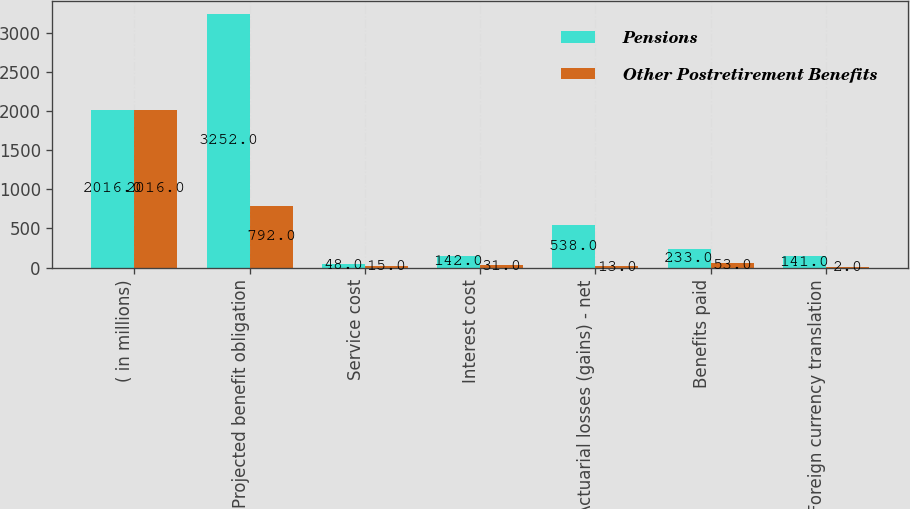Convert chart. <chart><loc_0><loc_0><loc_500><loc_500><stacked_bar_chart><ecel><fcel>( in millions)<fcel>Projected benefit obligation<fcel>Service cost<fcel>Interest cost<fcel>Actuarial losses (gains) - net<fcel>Benefits paid<fcel>Foreign currency translation<nl><fcel>Pensions<fcel>2016<fcel>3252<fcel>48<fcel>142<fcel>538<fcel>233<fcel>141<nl><fcel>Other Postretirement Benefits<fcel>2016<fcel>792<fcel>15<fcel>31<fcel>13<fcel>53<fcel>2<nl></chart> 